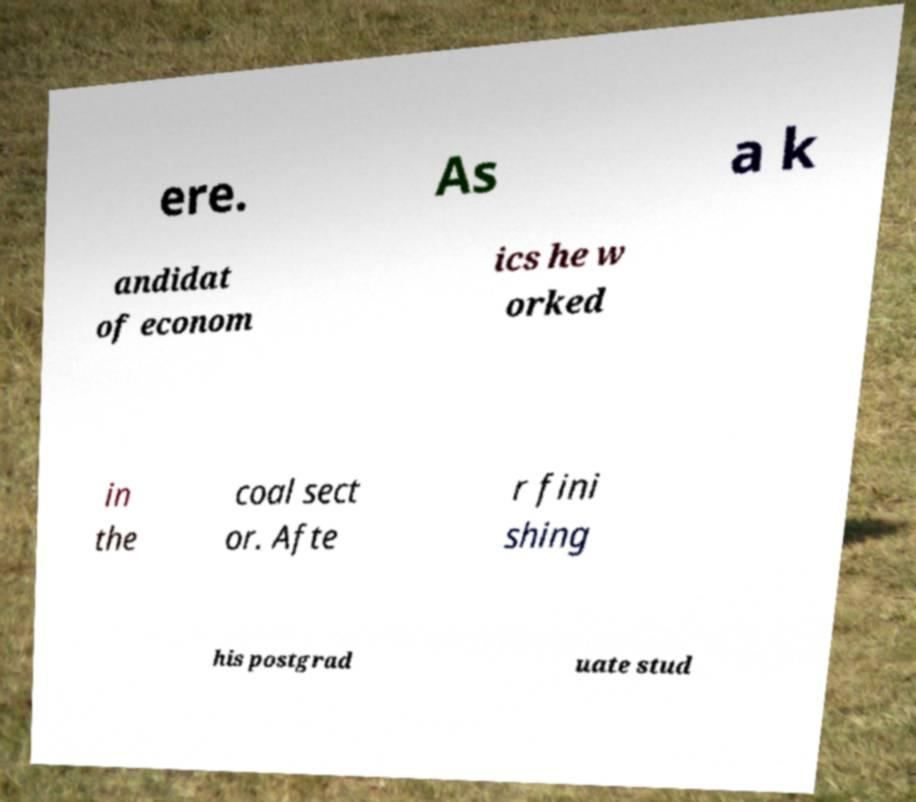Can you accurately transcribe the text from the provided image for me? ere. As a k andidat of econom ics he w orked in the coal sect or. Afte r fini shing his postgrad uate stud 